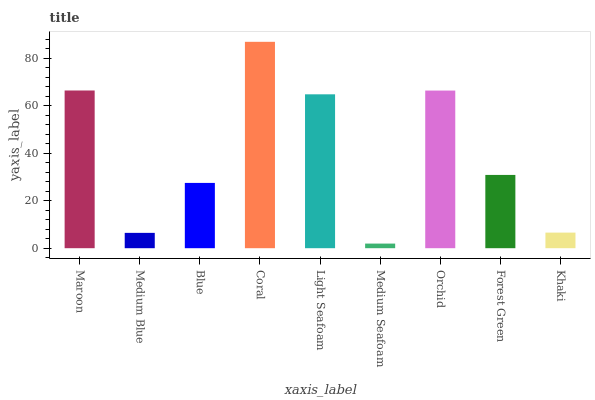Is Medium Blue the minimum?
Answer yes or no. No. Is Medium Blue the maximum?
Answer yes or no. No. Is Maroon greater than Medium Blue?
Answer yes or no. Yes. Is Medium Blue less than Maroon?
Answer yes or no. Yes. Is Medium Blue greater than Maroon?
Answer yes or no. No. Is Maroon less than Medium Blue?
Answer yes or no. No. Is Forest Green the high median?
Answer yes or no. Yes. Is Forest Green the low median?
Answer yes or no. Yes. Is Blue the high median?
Answer yes or no. No. Is Blue the low median?
Answer yes or no. No. 